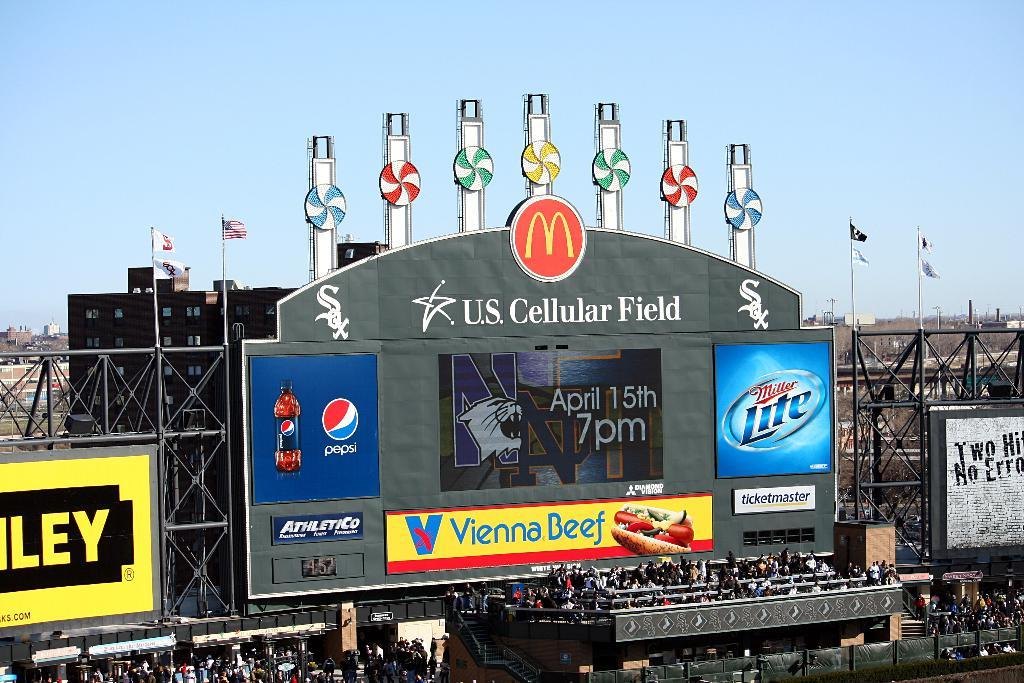<image>
Render a clear and concise summary of the photo. a stadium that has the US Cellular Field written on it 